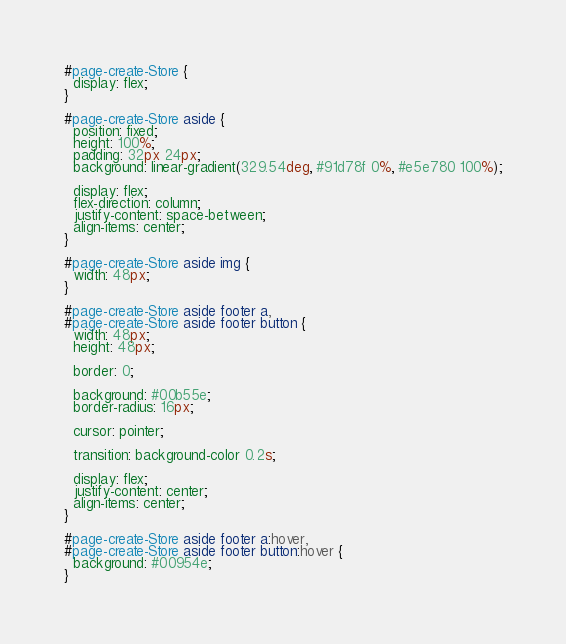Convert code to text. <code><loc_0><loc_0><loc_500><loc_500><_CSS_>#page-create-Store {
  display: flex;
}

#page-create-Store aside {
  position: fixed;
  height: 100%;
  padding: 32px 24px;
  background: linear-gradient(329.54deg, #91d78f 0%, #e5e780 100%);

  display: flex;
  flex-direction: column;
  justify-content: space-between;
  align-items: center;
}

#page-create-Store aside img {
  width: 48px;
}

#page-create-Store aside footer a,
#page-create-Store aside footer button {
  width: 48px;
  height: 48px;

  border: 0;

  background: #00b55e;
  border-radius: 16px;

  cursor: pointer;

  transition: background-color 0.2s;

  display: flex;
  justify-content: center;
  align-items: center;
}

#page-create-Store aside footer a:hover,
#page-create-Store aside footer button:hover {
  background: #00954e;
}
</code> 